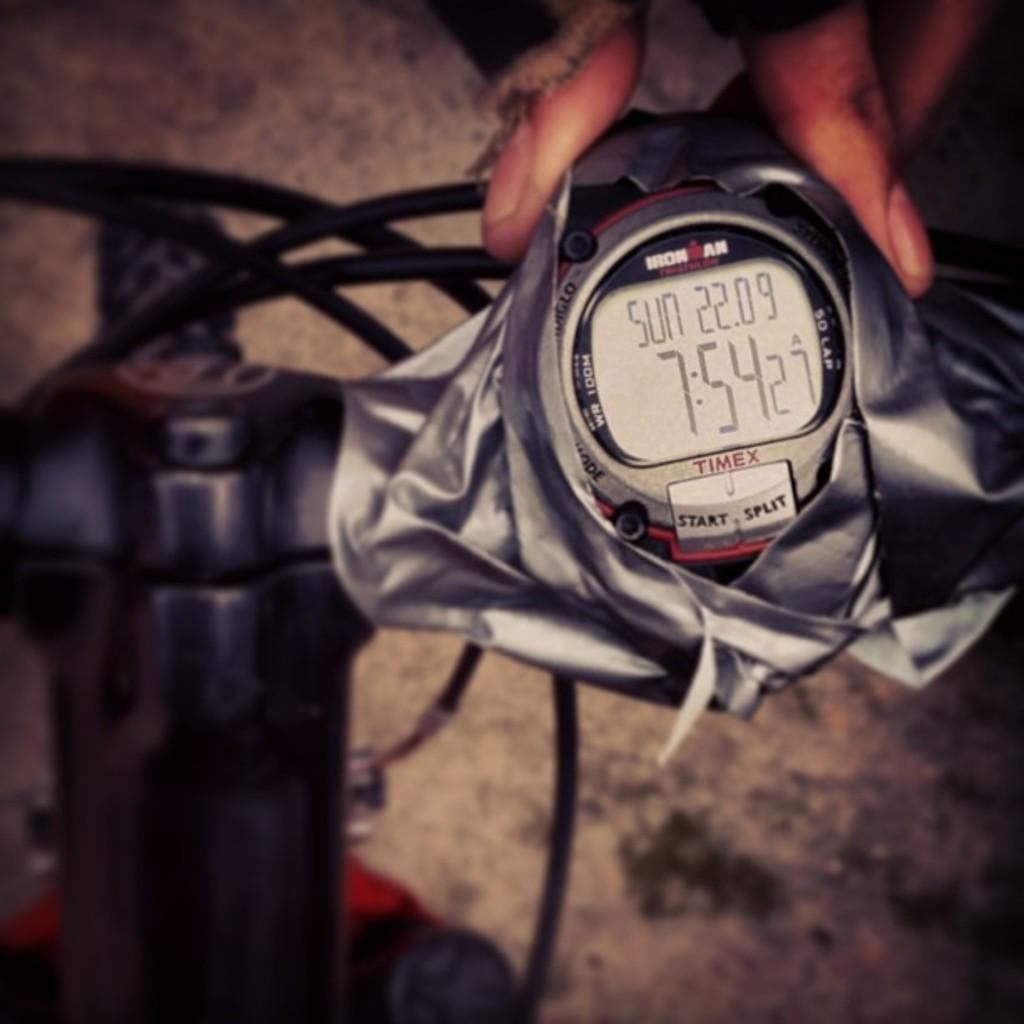<image>
Create a compact narrative representing the image presented. Iron AM watch taped ontop a bicycle outdoors. 